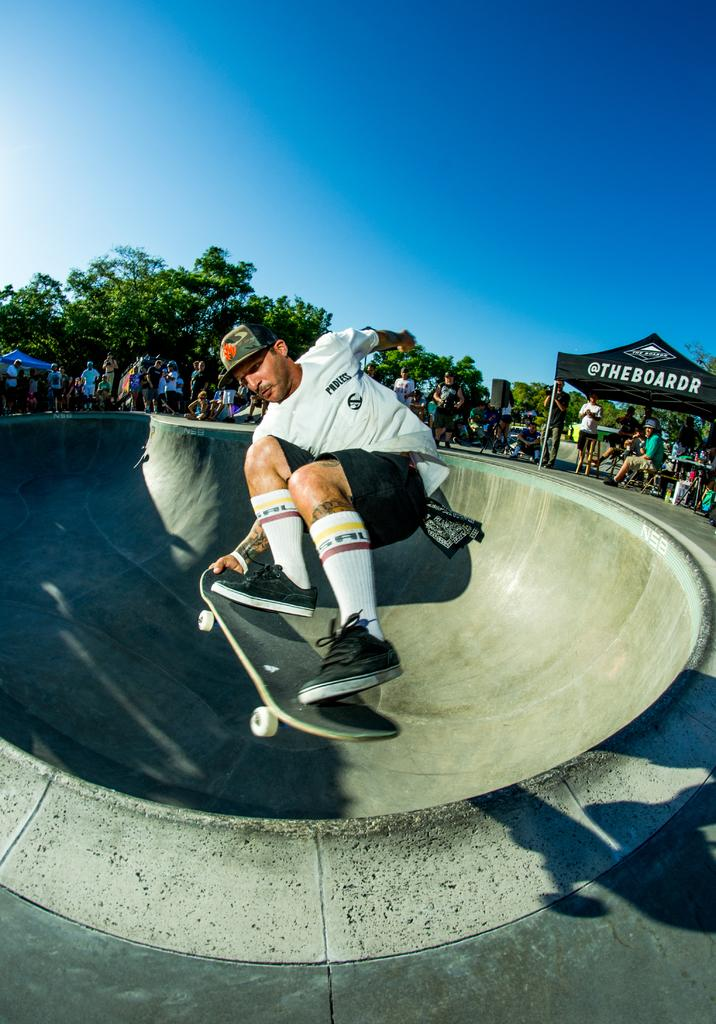What is the man in the image doing? The man is on a skateboard in the image. What can be seen in the background of the image? There are people and trees visible in the background of the image. What structure is located on the right side of the image? There is a tent on the right side of the image. What is the color of the sky in the image? The sky is blue in color. Can you see the man's daughter wearing a crown in the image? There is no mention of a daughter or a crown in the image. Is there a window visible in the image? There is no window mentioned or visible in the image. 